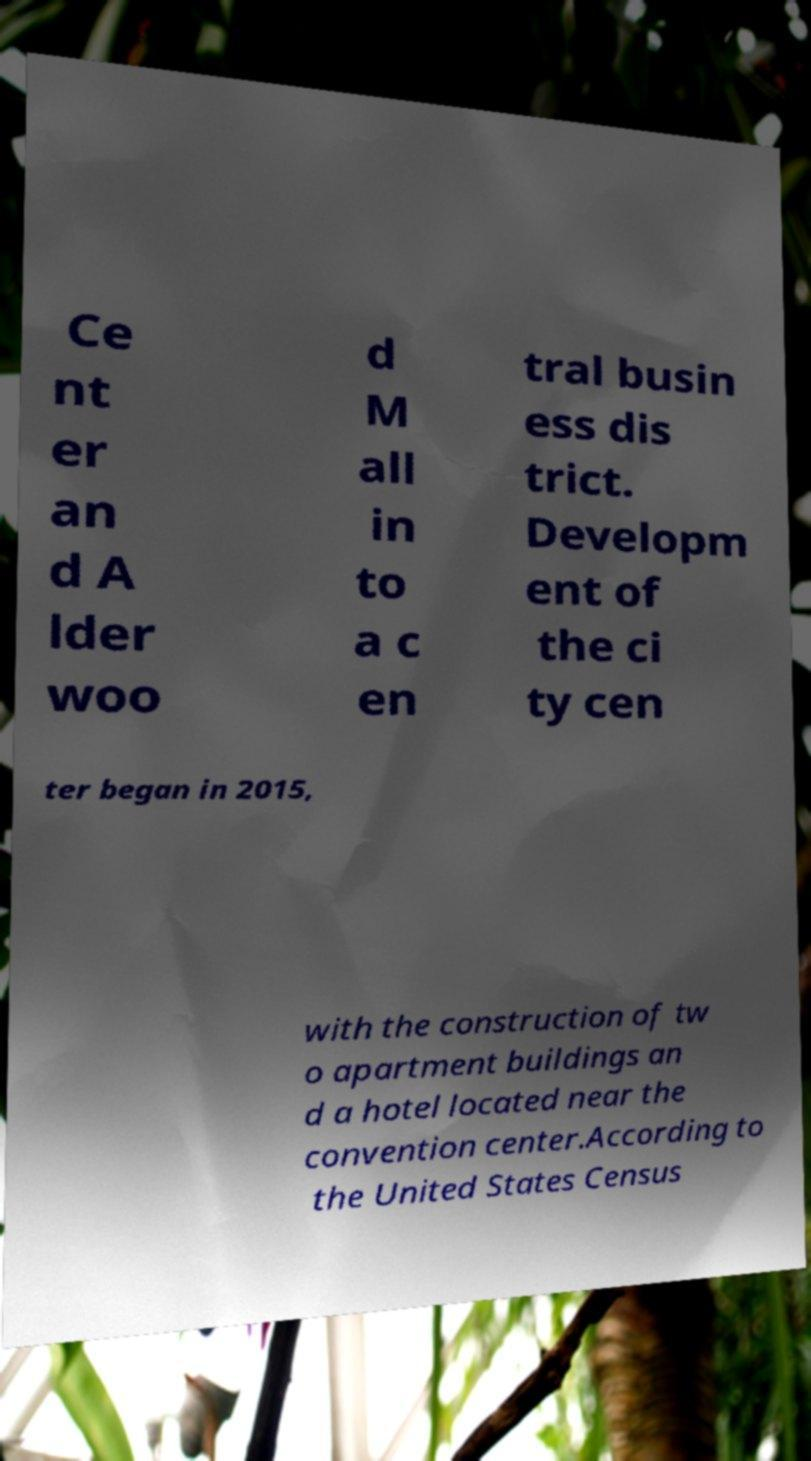Please identify and transcribe the text found in this image. Ce nt er an d A lder woo d M all in to a c en tral busin ess dis trict. Developm ent of the ci ty cen ter began in 2015, with the construction of tw o apartment buildings an d a hotel located near the convention center.According to the United States Census 